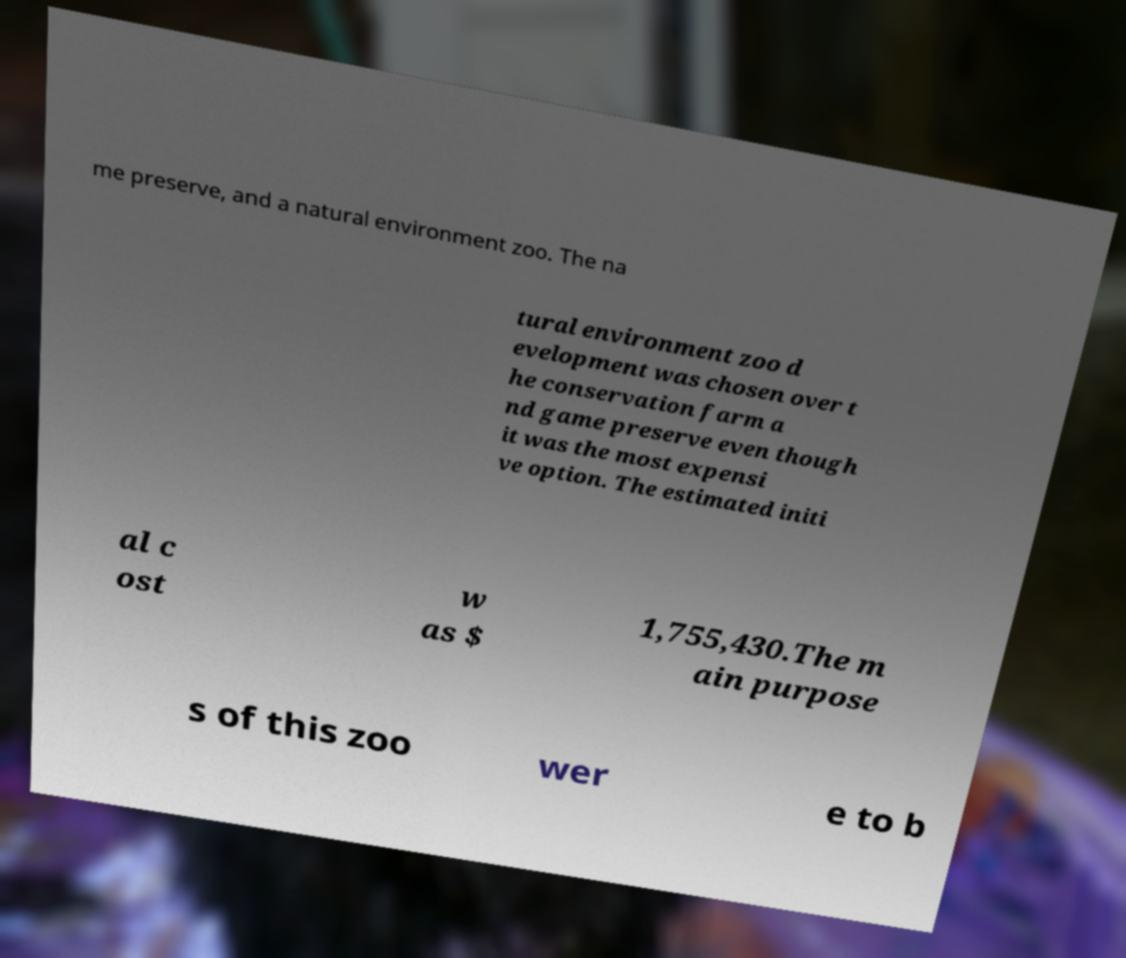Could you extract and type out the text from this image? me preserve, and a natural environment zoo. The na tural environment zoo d evelopment was chosen over t he conservation farm a nd game preserve even though it was the most expensi ve option. The estimated initi al c ost w as $ 1,755,430.The m ain purpose s of this zoo wer e to b 